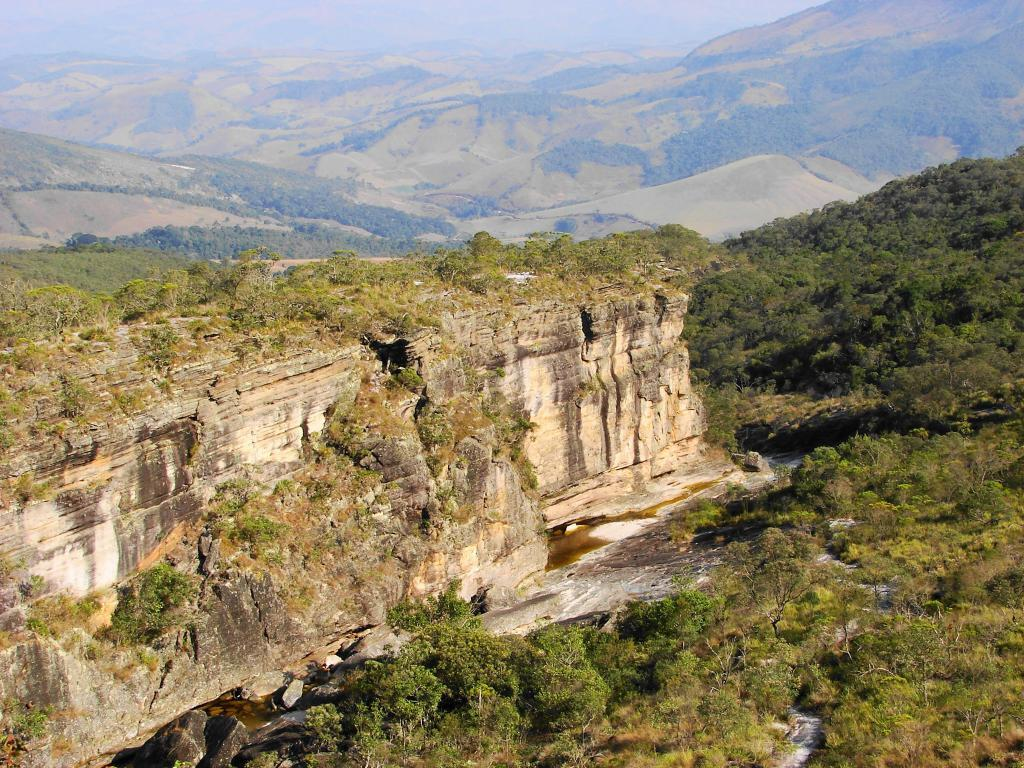What type of geological formation is in the image? There is a rock hill in the image. What can be seen growing on the rock hill? There are plants on the rock hill. What is present on the top of the rock hill? There are plants and grass on the top of the rock hill. What can be seen in the distance behind the rock hill? There are many hills visible in the background of the image, and trees are present on those hills. What type of scarf is draped over the trees in the image? There is no scarf present in the image; it features a rock hill with plants and trees. How much dust can be seen on the plants in the image? There is no mention of dust in the image, and it is not possible to determine the presence or absence of dust from the provided facts. 